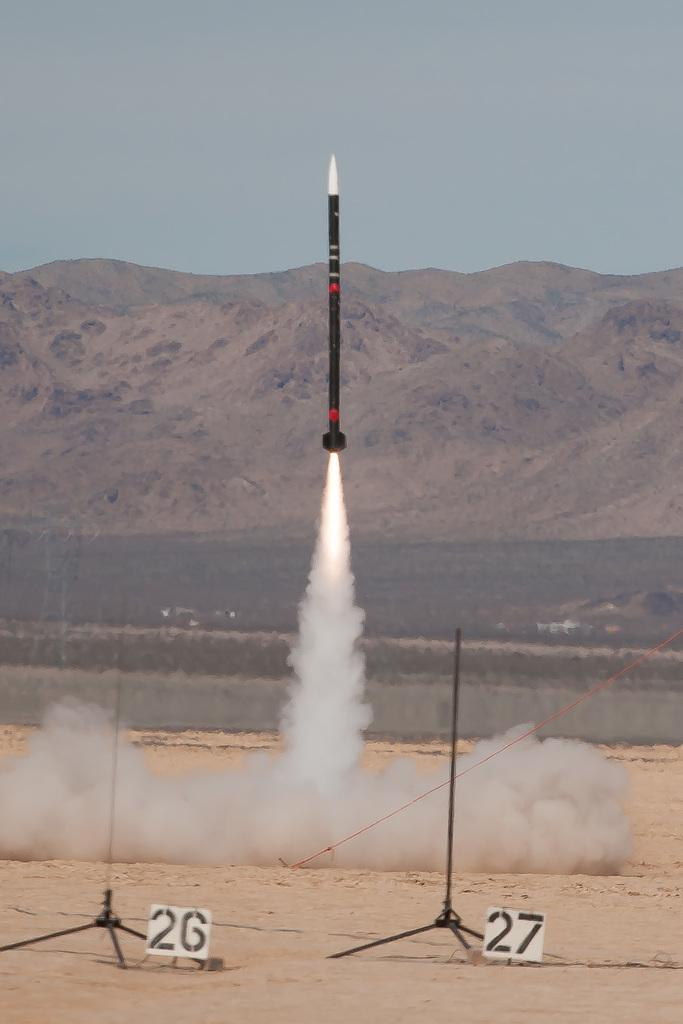What is the main subject of the image? The main subject of the image is a satellite. What can be seen around the satellite? There is smoke visible in the image. What objects are present in the image besides the satellite? There are boards in the image. What is visible in the background of the image? There is a mountain and the sky visible in the background of the image. What type of heart can be seen beating in the image? There is no heart present in the image; it features a satellite, smoke, boards, a mountain, and the sky. 